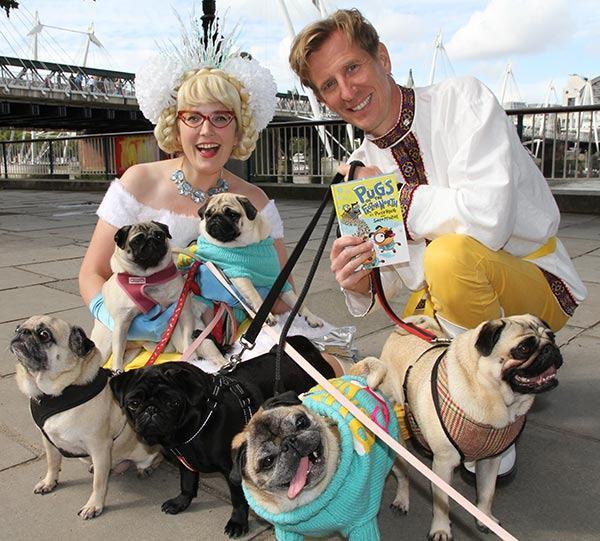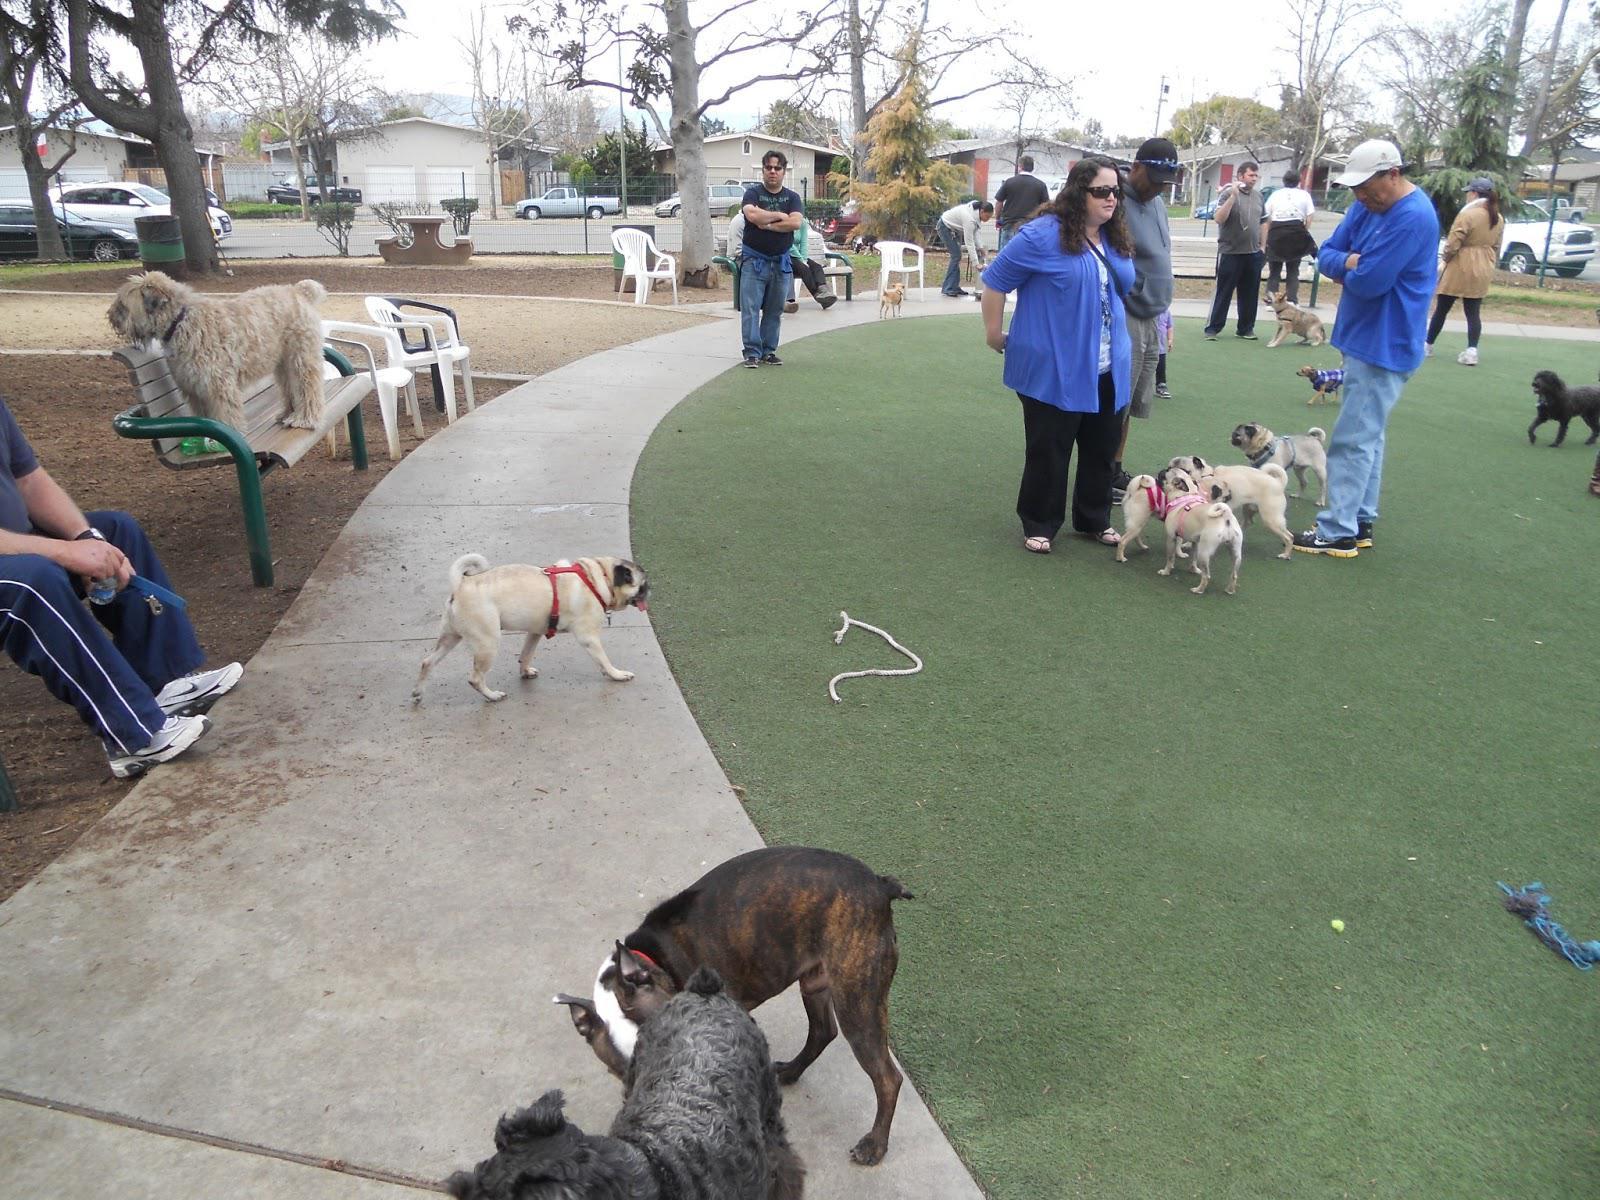The first image is the image on the left, the second image is the image on the right. For the images displayed, is the sentence "One image contains fewer than 3 pugs, and all pugs are on a leash." factually correct? Answer yes or no. No. 